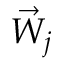Convert formula to latex. <formula><loc_0><loc_0><loc_500><loc_500>\vec { W } _ { j }</formula> 